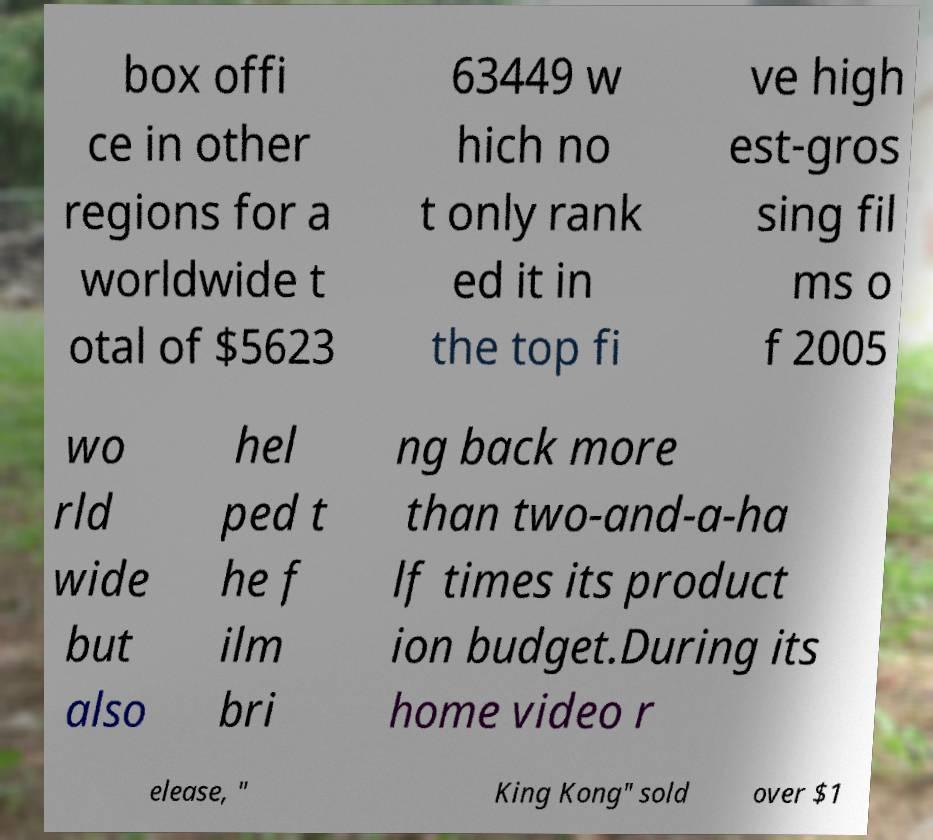There's text embedded in this image that I need extracted. Can you transcribe it verbatim? box offi ce in other regions for a worldwide t otal of $5623 63449 w hich no t only rank ed it in the top fi ve high est-gros sing fil ms o f 2005 wo rld wide but also hel ped t he f ilm bri ng back more than two-and-a-ha lf times its product ion budget.During its home video r elease, " King Kong" sold over $1 